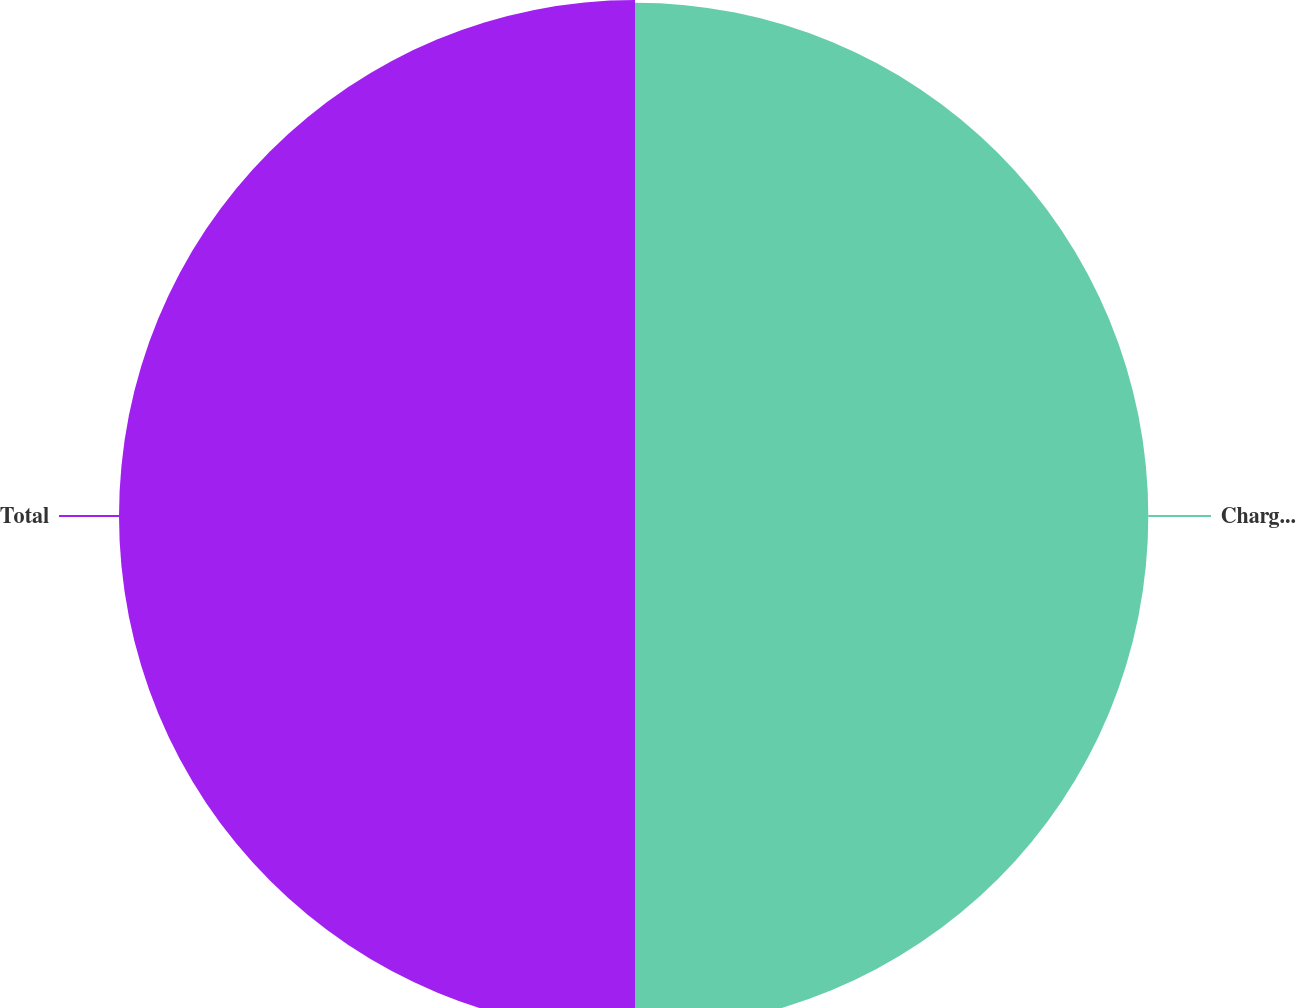Convert chart. <chart><loc_0><loc_0><loc_500><loc_500><pie_chart><fcel>Charges associated with<fcel>Total<nl><fcel>49.87%<fcel>50.13%<nl></chart> 